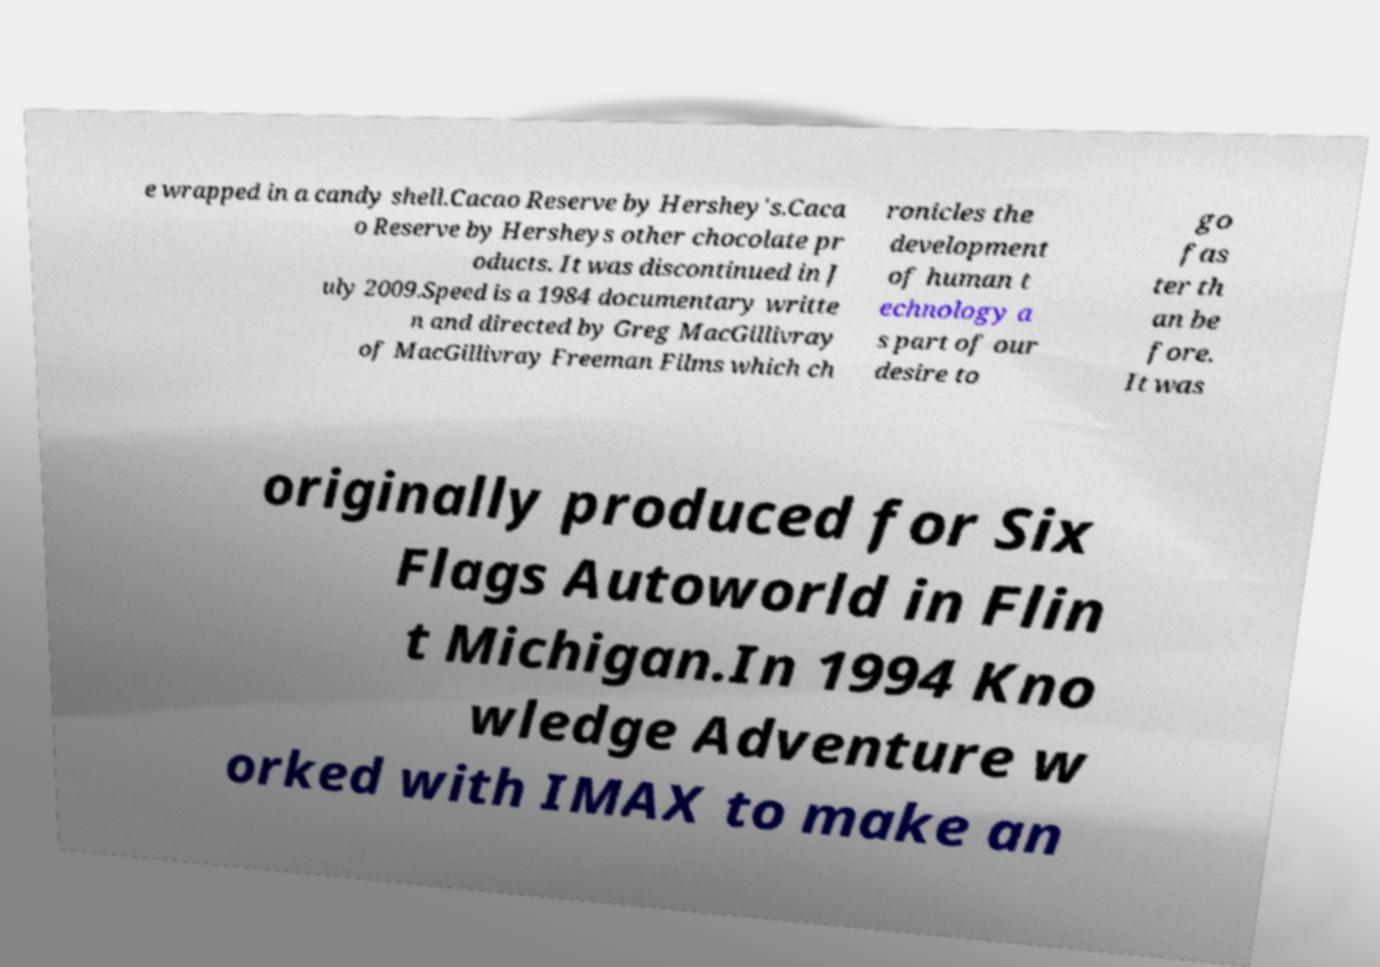I need the written content from this picture converted into text. Can you do that? e wrapped in a candy shell.Cacao Reserve by Hershey's.Caca o Reserve by Hersheys other chocolate pr oducts. It was discontinued in J uly 2009.Speed is a 1984 documentary writte n and directed by Greg MacGillivray of MacGillivray Freeman Films which ch ronicles the development of human t echnology a s part of our desire to go fas ter th an be fore. It was originally produced for Six Flags Autoworld in Flin t Michigan.In 1994 Kno wledge Adventure w orked with IMAX to make an 